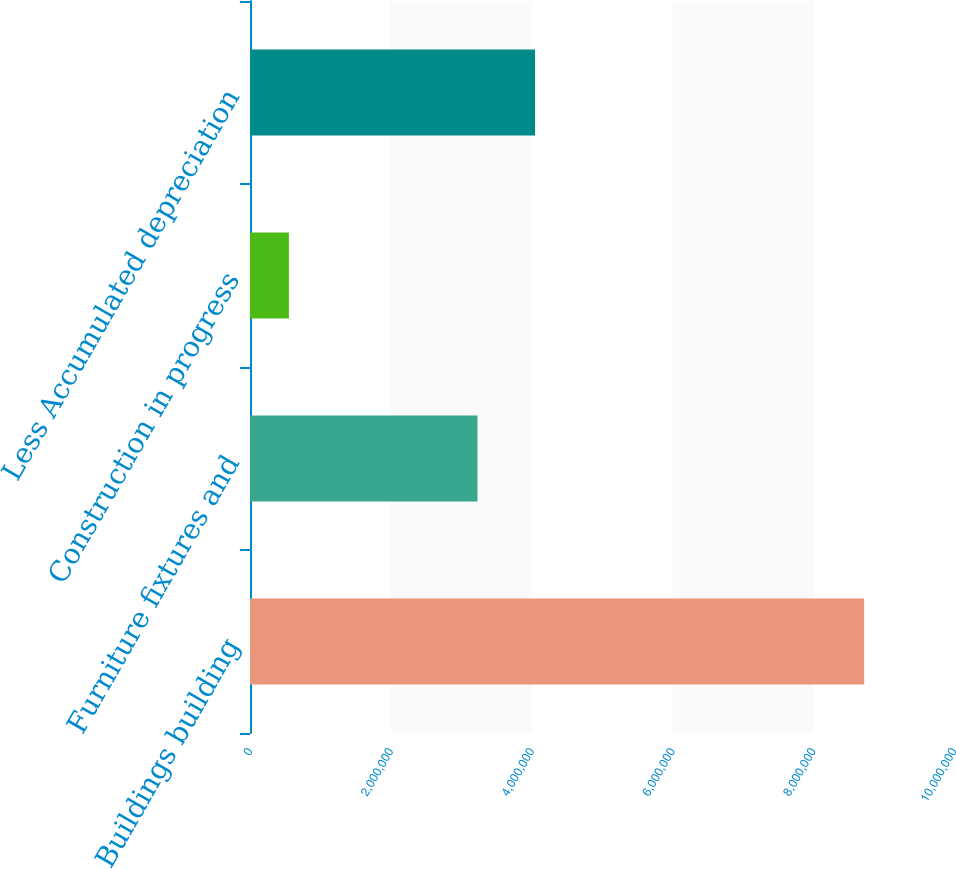Convert chart. <chart><loc_0><loc_0><loc_500><loc_500><bar_chart><fcel>Buildings building<fcel>Furniture fixtures and<fcel>Construction in progress<fcel>Less Accumulated depreciation<nl><fcel>8.72434e+06<fcel>3.23172e+06<fcel>552667<fcel>4.04889e+06<nl></chart> 